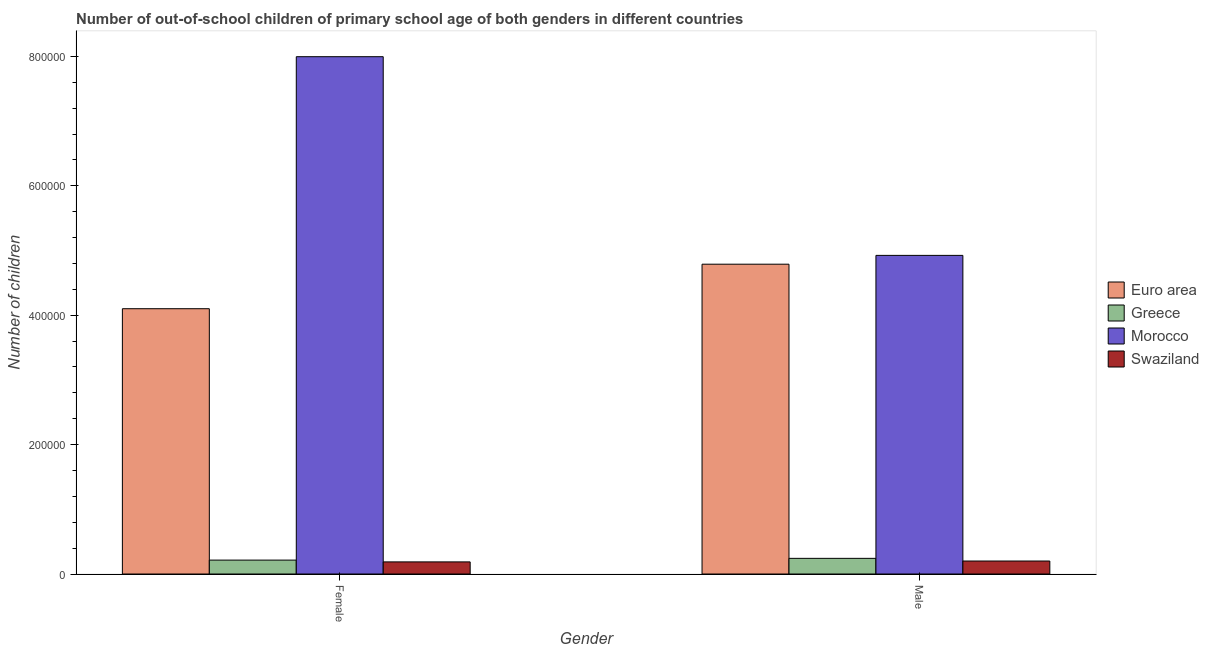How many different coloured bars are there?
Ensure brevity in your answer.  4. How many groups of bars are there?
Provide a short and direct response. 2. How many bars are there on the 1st tick from the right?
Ensure brevity in your answer.  4. What is the label of the 1st group of bars from the left?
Keep it short and to the point. Female. What is the number of female out-of-school students in Swaziland?
Your answer should be very brief. 1.87e+04. Across all countries, what is the maximum number of female out-of-school students?
Give a very brief answer. 7.99e+05. Across all countries, what is the minimum number of male out-of-school students?
Offer a terse response. 2.01e+04. In which country was the number of male out-of-school students maximum?
Give a very brief answer. Morocco. In which country was the number of male out-of-school students minimum?
Offer a very short reply. Swaziland. What is the total number of female out-of-school students in the graph?
Give a very brief answer. 1.25e+06. What is the difference between the number of male out-of-school students in Euro area and that in Swaziland?
Provide a succinct answer. 4.59e+05. What is the difference between the number of female out-of-school students in Swaziland and the number of male out-of-school students in Greece?
Your response must be concise. -5485. What is the average number of female out-of-school students per country?
Offer a very short reply. 3.12e+05. What is the difference between the number of male out-of-school students and number of female out-of-school students in Morocco?
Keep it short and to the point. -3.07e+05. What is the ratio of the number of male out-of-school students in Swaziland to that in Morocco?
Offer a very short reply. 0.04. In how many countries, is the number of female out-of-school students greater than the average number of female out-of-school students taken over all countries?
Give a very brief answer. 2. What does the 4th bar from the left in Female represents?
Provide a succinct answer. Swaziland. What does the 3rd bar from the right in Female represents?
Your answer should be very brief. Greece. How many countries are there in the graph?
Your answer should be compact. 4. What is the difference between two consecutive major ticks on the Y-axis?
Your answer should be very brief. 2.00e+05. Where does the legend appear in the graph?
Your answer should be compact. Center right. How are the legend labels stacked?
Provide a short and direct response. Vertical. What is the title of the graph?
Provide a succinct answer. Number of out-of-school children of primary school age of both genders in different countries. Does "Gambia, The" appear as one of the legend labels in the graph?
Provide a short and direct response. No. What is the label or title of the X-axis?
Your answer should be very brief. Gender. What is the label or title of the Y-axis?
Provide a succinct answer. Number of children. What is the Number of children in Euro area in Female?
Your response must be concise. 4.10e+05. What is the Number of children of Greece in Female?
Give a very brief answer. 2.15e+04. What is the Number of children in Morocco in Female?
Your answer should be very brief. 7.99e+05. What is the Number of children of Swaziland in Female?
Offer a very short reply. 1.87e+04. What is the Number of children of Euro area in Male?
Keep it short and to the point. 4.79e+05. What is the Number of children of Greece in Male?
Provide a succinct answer. 2.42e+04. What is the Number of children in Morocco in Male?
Your answer should be very brief. 4.92e+05. What is the Number of children of Swaziland in Male?
Provide a short and direct response. 2.01e+04. Across all Gender, what is the maximum Number of children in Euro area?
Provide a short and direct response. 4.79e+05. Across all Gender, what is the maximum Number of children of Greece?
Your response must be concise. 2.42e+04. Across all Gender, what is the maximum Number of children of Morocco?
Your answer should be very brief. 7.99e+05. Across all Gender, what is the maximum Number of children of Swaziland?
Ensure brevity in your answer.  2.01e+04. Across all Gender, what is the minimum Number of children of Euro area?
Offer a terse response. 4.10e+05. Across all Gender, what is the minimum Number of children in Greece?
Your answer should be very brief. 2.15e+04. Across all Gender, what is the minimum Number of children of Morocco?
Offer a very short reply. 4.92e+05. Across all Gender, what is the minimum Number of children in Swaziland?
Your response must be concise. 1.87e+04. What is the total Number of children in Euro area in the graph?
Your answer should be very brief. 8.89e+05. What is the total Number of children of Greece in the graph?
Offer a very short reply. 4.57e+04. What is the total Number of children in Morocco in the graph?
Give a very brief answer. 1.29e+06. What is the total Number of children in Swaziland in the graph?
Give a very brief answer. 3.88e+04. What is the difference between the Number of children in Euro area in Female and that in Male?
Provide a succinct answer. -6.88e+04. What is the difference between the Number of children of Greece in Female and that in Male?
Offer a terse response. -2727. What is the difference between the Number of children in Morocco in Female and that in Male?
Offer a terse response. 3.07e+05. What is the difference between the Number of children of Swaziland in Female and that in Male?
Your answer should be very brief. -1340. What is the difference between the Number of children in Euro area in Female and the Number of children in Greece in Male?
Give a very brief answer. 3.86e+05. What is the difference between the Number of children in Euro area in Female and the Number of children in Morocco in Male?
Your answer should be compact. -8.24e+04. What is the difference between the Number of children in Euro area in Female and the Number of children in Swaziland in Male?
Provide a short and direct response. 3.90e+05. What is the difference between the Number of children of Greece in Female and the Number of children of Morocco in Male?
Offer a very short reply. -4.71e+05. What is the difference between the Number of children in Greece in Female and the Number of children in Swaziland in Male?
Your response must be concise. 1418. What is the difference between the Number of children of Morocco in Female and the Number of children of Swaziland in Male?
Make the answer very short. 7.79e+05. What is the average Number of children of Euro area per Gender?
Offer a terse response. 4.44e+05. What is the average Number of children of Greece per Gender?
Offer a very short reply. 2.28e+04. What is the average Number of children in Morocco per Gender?
Make the answer very short. 6.46e+05. What is the average Number of children in Swaziland per Gender?
Your answer should be very brief. 1.94e+04. What is the difference between the Number of children in Euro area and Number of children in Greece in Female?
Provide a succinct answer. 3.89e+05. What is the difference between the Number of children in Euro area and Number of children in Morocco in Female?
Your answer should be very brief. -3.89e+05. What is the difference between the Number of children of Euro area and Number of children of Swaziland in Female?
Provide a short and direct response. 3.91e+05. What is the difference between the Number of children of Greece and Number of children of Morocco in Female?
Your response must be concise. -7.78e+05. What is the difference between the Number of children of Greece and Number of children of Swaziland in Female?
Provide a short and direct response. 2758. What is the difference between the Number of children of Morocco and Number of children of Swaziland in Female?
Keep it short and to the point. 7.81e+05. What is the difference between the Number of children of Euro area and Number of children of Greece in Male?
Ensure brevity in your answer.  4.55e+05. What is the difference between the Number of children in Euro area and Number of children in Morocco in Male?
Offer a terse response. -1.36e+04. What is the difference between the Number of children of Euro area and Number of children of Swaziland in Male?
Offer a very short reply. 4.59e+05. What is the difference between the Number of children of Greece and Number of children of Morocco in Male?
Offer a very short reply. -4.68e+05. What is the difference between the Number of children of Greece and Number of children of Swaziland in Male?
Your answer should be very brief. 4145. What is the difference between the Number of children of Morocco and Number of children of Swaziland in Male?
Provide a succinct answer. 4.72e+05. What is the ratio of the Number of children in Euro area in Female to that in Male?
Provide a short and direct response. 0.86. What is the ratio of the Number of children of Greece in Female to that in Male?
Your answer should be very brief. 0.89. What is the ratio of the Number of children in Morocco in Female to that in Male?
Make the answer very short. 1.62. What is the ratio of the Number of children in Swaziland in Female to that in Male?
Your answer should be compact. 0.93. What is the difference between the highest and the second highest Number of children in Euro area?
Give a very brief answer. 6.88e+04. What is the difference between the highest and the second highest Number of children in Greece?
Offer a terse response. 2727. What is the difference between the highest and the second highest Number of children of Morocco?
Offer a very short reply. 3.07e+05. What is the difference between the highest and the second highest Number of children of Swaziland?
Make the answer very short. 1340. What is the difference between the highest and the lowest Number of children in Euro area?
Offer a terse response. 6.88e+04. What is the difference between the highest and the lowest Number of children of Greece?
Your answer should be compact. 2727. What is the difference between the highest and the lowest Number of children in Morocco?
Ensure brevity in your answer.  3.07e+05. What is the difference between the highest and the lowest Number of children of Swaziland?
Keep it short and to the point. 1340. 